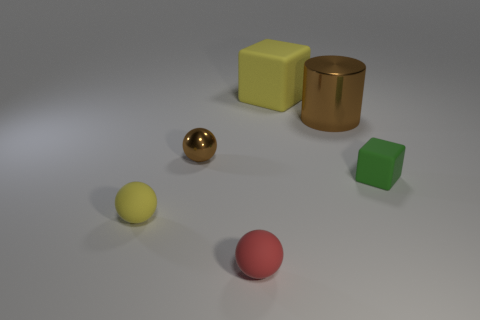Add 1 small blue matte blocks. How many objects exist? 7 Subtract all cylinders. How many objects are left? 5 Subtract 0 cyan cylinders. How many objects are left? 6 Subtract all big rubber things. Subtract all big blue cylinders. How many objects are left? 5 Add 3 red rubber spheres. How many red rubber spheres are left? 4 Add 6 tiny red rubber objects. How many tiny red rubber objects exist? 7 